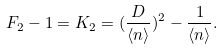<formula> <loc_0><loc_0><loc_500><loc_500>F _ { 2 } - 1 = K _ { 2 } = ( \frac { D } { \langle n \rangle } ) ^ { 2 } - \frac { 1 } { \langle n \rangle } .</formula> 